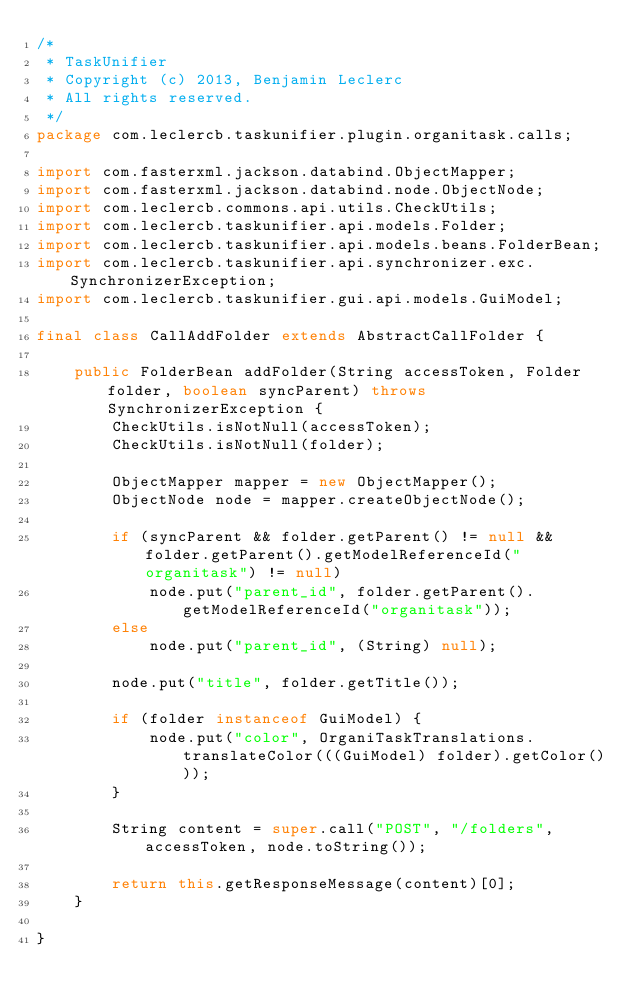<code> <loc_0><loc_0><loc_500><loc_500><_Java_>/*
 * TaskUnifier
 * Copyright (c) 2013, Benjamin Leclerc
 * All rights reserved.
 */
package com.leclercb.taskunifier.plugin.organitask.calls;

import com.fasterxml.jackson.databind.ObjectMapper;
import com.fasterxml.jackson.databind.node.ObjectNode;
import com.leclercb.commons.api.utils.CheckUtils;
import com.leclercb.taskunifier.api.models.Folder;
import com.leclercb.taskunifier.api.models.beans.FolderBean;
import com.leclercb.taskunifier.api.synchronizer.exc.SynchronizerException;
import com.leclercb.taskunifier.gui.api.models.GuiModel;

final class CallAddFolder extends AbstractCallFolder {

    public FolderBean addFolder(String accessToken, Folder folder, boolean syncParent) throws SynchronizerException {
        CheckUtils.isNotNull(accessToken);
        CheckUtils.isNotNull(folder);

        ObjectMapper mapper = new ObjectMapper();
        ObjectNode node = mapper.createObjectNode();

        if (syncParent && folder.getParent() != null && folder.getParent().getModelReferenceId("organitask") != null)
            node.put("parent_id", folder.getParent().getModelReferenceId("organitask"));
        else
            node.put("parent_id", (String) null);

        node.put("title", folder.getTitle());

        if (folder instanceof GuiModel) {
            node.put("color", OrganiTaskTranslations.translateColor(((GuiModel) folder).getColor()));
        }

        String content = super.call("POST", "/folders", accessToken, node.toString());

        return this.getResponseMessage(content)[0];
    }

}
</code> 